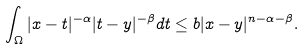<formula> <loc_0><loc_0><loc_500><loc_500>\int _ { \Omega } | x - t | ^ { - \alpha } | t - y | ^ { - \beta } d t \leq b | x - y | ^ { n - \alpha - \beta } .</formula> 